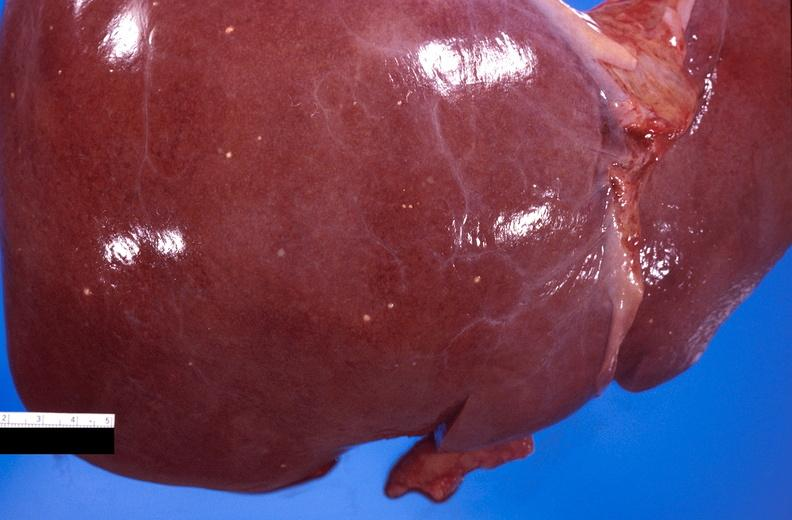s hepatobiliary present?
Answer the question using a single word or phrase. Yes 